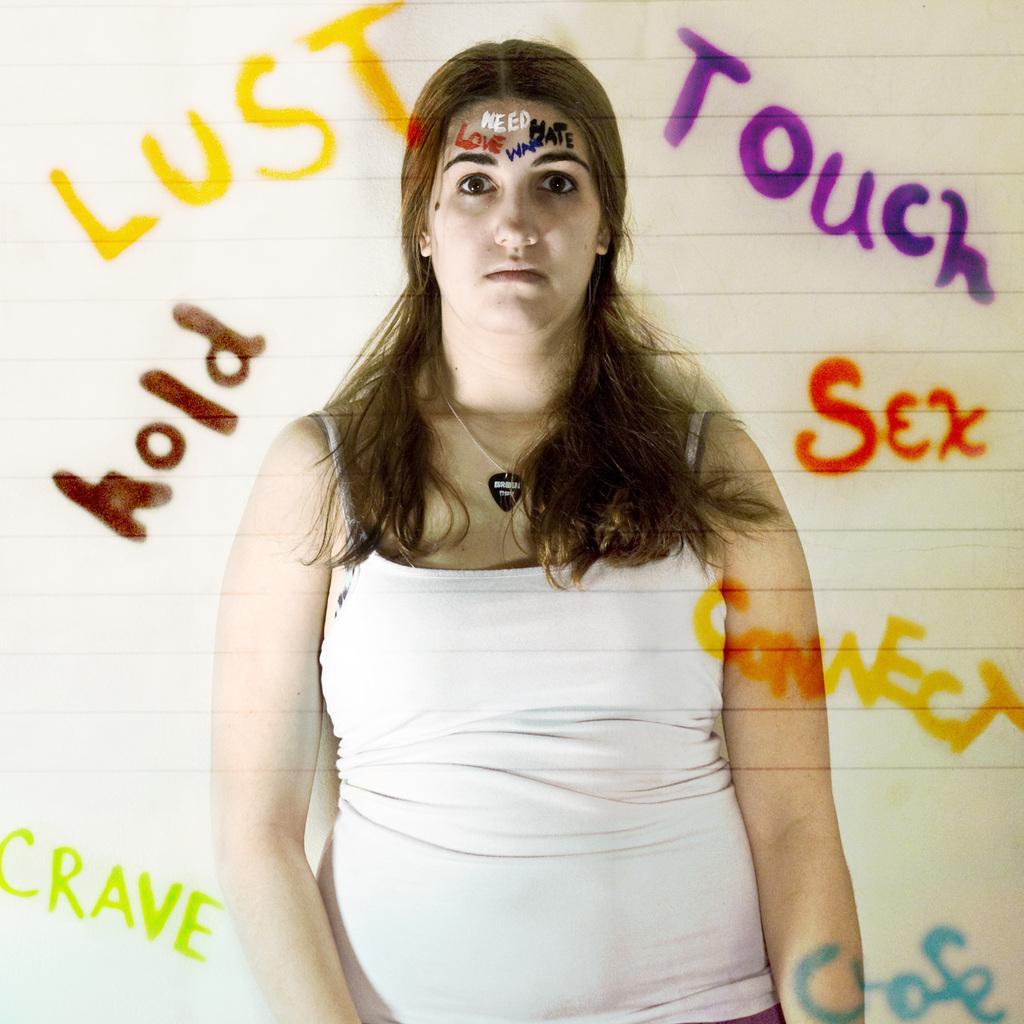Could you give a brief overview of what you see in this image? In this picture, we can see a lady and some text on the forehead, we can see some text on the background. 